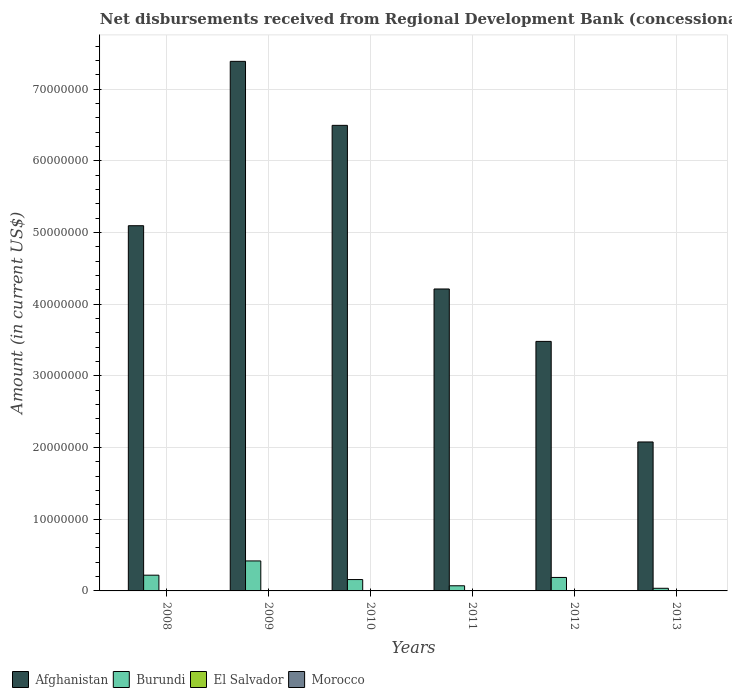How many different coloured bars are there?
Your response must be concise. 2. How many groups of bars are there?
Your response must be concise. 6. Are the number of bars per tick equal to the number of legend labels?
Make the answer very short. No. Are the number of bars on each tick of the X-axis equal?
Provide a short and direct response. Yes. How many bars are there on the 1st tick from the left?
Offer a very short reply. 2. What is the label of the 6th group of bars from the left?
Provide a succinct answer. 2013. What is the amount of disbursements received from Regional Development Bank in Afghanistan in 2008?
Ensure brevity in your answer.  5.09e+07. Across all years, what is the maximum amount of disbursements received from Regional Development Bank in Afghanistan?
Your answer should be very brief. 7.39e+07. In which year was the amount of disbursements received from Regional Development Bank in Burundi maximum?
Keep it short and to the point. 2009. What is the total amount of disbursements received from Regional Development Bank in Afghanistan in the graph?
Your response must be concise. 2.87e+08. What is the difference between the amount of disbursements received from Regional Development Bank in Burundi in 2008 and that in 2010?
Make the answer very short. 6.10e+05. What is the difference between the amount of disbursements received from Regional Development Bank in El Salvador in 2010 and the amount of disbursements received from Regional Development Bank in Burundi in 2013?
Offer a very short reply. -3.68e+05. What is the average amount of disbursements received from Regional Development Bank in Burundi per year?
Give a very brief answer. 1.82e+06. In the year 2013, what is the difference between the amount of disbursements received from Regional Development Bank in Afghanistan and amount of disbursements received from Regional Development Bank in Burundi?
Make the answer very short. 2.04e+07. In how many years, is the amount of disbursements received from Regional Development Bank in Afghanistan greater than 28000000 US$?
Ensure brevity in your answer.  5. What is the ratio of the amount of disbursements received from Regional Development Bank in Burundi in 2011 to that in 2012?
Make the answer very short. 0.38. Is the amount of disbursements received from Regional Development Bank in Afghanistan in 2009 less than that in 2010?
Your answer should be compact. No. What is the difference between the highest and the second highest amount of disbursements received from Regional Development Bank in Burundi?
Your answer should be compact. 1.99e+06. What is the difference between the highest and the lowest amount of disbursements received from Regional Development Bank in Burundi?
Your response must be concise. 3.82e+06. In how many years, is the amount of disbursements received from Regional Development Bank in Morocco greater than the average amount of disbursements received from Regional Development Bank in Morocco taken over all years?
Provide a short and direct response. 0. Is the sum of the amount of disbursements received from Regional Development Bank in Burundi in 2012 and 2013 greater than the maximum amount of disbursements received from Regional Development Bank in Afghanistan across all years?
Give a very brief answer. No. Is it the case that in every year, the sum of the amount of disbursements received from Regional Development Bank in Burundi and amount of disbursements received from Regional Development Bank in El Salvador is greater than the amount of disbursements received from Regional Development Bank in Morocco?
Make the answer very short. Yes. What is the difference between two consecutive major ticks on the Y-axis?
Make the answer very short. 1.00e+07. Are the values on the major ticks of Y-axis written in scientific E-notation?
Give a very brief answer. No. Does the graph contain grids?
Keep it short and to the point. Yes. How many legend labels are there?
Provide a succinct answer. 4. How are the legend labels stacked?
Keep it short and to the point. Horizontal. What is the title of the graph?
Provide a succinct answer. Net disbursements received from Regional Development Bank (concessional). Does "Georgia" appear as one of the legend labels in the graph?
Your answer should be very brief. No. What is the label or title of the X-axis?
Your answer should be very brief. Years. What is the label or title of the Y-axis?
Your answer should be very brief. Amount (in current US$). What is the Amount (in current US$) of Afghanistan in 2008?
Keep it short and to the point. 5.09e+07. What is the Amount (in current US$) of Burundi in 2008?
Offer a terse response. 2.20e+06. What is the Amount (in current US$) in El Salvador in 2008?
Keep it short and to the point. 0. What is the Amount (in current US$) in Afghanistan in 2009?
Give a very brief answer. 7.39e+07. What is the Amount (in current US$) of Burundi in 2009?
Your response must be concise. 4.18e+06. What is the Amount (in current US$) of Morocco in 2009?
Your answer should be compact. 0. What is the Amount (in current US$) in Afghanistan in 2010?
Offer a very short reply. 6.49e+07. What is the Amount (in current US$) in Burundi in 2010?
Provide a short and direct response. 1.59e+06. What is the Amount (in current US$) in Afghanistan in 2011?
Ensure brevity in your answer.  4.21e+07. What is the Amount (in current US$) of Burundi in 2011?
Your answer should be compact. 7.18e+05. What is the Amount (in current US$) of Morocco in 2011?
Provide a succinct answer. 0. What is the Amount (in current US$) of Afghanistan in 2012?
Make the answer very short. 3.48e+07. What is the Amount (in current US$) in Burundi in 2012?
Keep it short and to the point. 1.88e+06. What is the Amount (in current US$) of El Salvador in 2012?
Give a very brief answer. 0. What is the Amount (in current US$) in Morocco in 2012?
Your answer should be compact. 0. What is the Amount (in current US$) of Afghanistan in 2013?
Your answer should be very brief. 2.08e+07. What is the Amount (in current US$) in Burundi in 2013?
Your answer should be very brief. 3.68e+05. What is the Amount (in current US$) of El Salvador in 2013?
Give a very brief answer. 0. What is the Amount (in current US$) of Morocco in 2013?
Provide a short and direct response. 0. Across all years, what is the maximum Amount (in current US$) of Afghanistan?
Your response must be concise. 7.39e+07. Across all years, what is the maximum Amount (in current US$) of Burundi?
Give a very brief answer. 4.18e+06. Across all years, what is the minimum Amount (in current US$) in Afghanistan?
Keep it short and to the point. 2.08e+07. Across all years, what is the minimum Amount (in current US$) in Burundi?
Offer a very short reply. 3.68e+05. What is the total Amount (in current US$) in Afghanistan in the graph?
Provide a short and direct response. 2.87e+08. What is the total Amount (in current US$) of Burundi in the graph?
Provide a succinct answer. 1.09e+07. What is the total Amount (in current US$) in El Salvador in the graph?
Offer a terse response. 0. What is the difference between the Amount (in current US$) in Afghanistan in 2008 and that in 2009?
Ensure brevity in your answer.  -2.29e+07. What is the difference between the Amount (in current US$) of Burundi in 2008 and that in 2009?
Ensure brevity in your answer.  -1.99e+06. What is the difference between the Amount (in current US$) in Afghanistan in 2008 and that in 2010?
Provide a short and direct response. -1.40e+07. What is the difference between the Amount (in current US$) of Burundi in 2008 and that in 2010?
Provide a succinct answer. 6.10e+05. What is the difference between the Amount (in current US$) in Afghanistan in 2008 and that in 2011?
Offer a terse response. 8.82e+06. What is the difference between the Amount (in current US$) of Burundi in 2008 and that in 2011?
Provide a short and direct response. 1.48e+06. What is the difference between the Amount (in current US$) in Afghanistan in 2008 and that in 2012?
Your response must be concise. 1.61e+07. What is the difference between the Amount (in current US$) of Burundi in 2008 and that in 2012?
Offer a very short reply. 3.17e+05. What is the difference between the Amount (in current US$) in Afghanistan in 2008 and that in 2013?
Your answer should be very brief. 3.02e+07. What is the difference between the Amount (in current US$) of Burundi in 2008 and that in 2013?
Give a very brief answer. 1.83e+06. What is the difference between the Amount (in current US$) of Afghanistan in 2009 and that in 2010?
Offer a terse response. 8.93e+06. What is the difference between the Amount (in current US$) of Burundi in 2009 and that in 2010?
Make the answer very short. 2.60e+06. What is the difference between the Amount (in current US$) in Afghanistan in 2009 and that in 2011?
Your response must be concise. 3.17e+07. What is the difference between the Amount (in current US$) in Burundi in 2009 and that in 2011?
Offer a very short reply. 3.46e+06. What is the difference between the Amount (in current US$) of Afghanistan in 2009 and that in 2012?
Your answer should be very brief. 3.91e+07. What is the difference between the Amount (in current US$) in Burundi in 2009 and that in 2012?
Give a very brief answer. 2.30e+06. What is the difference between the Amount (in current US$) in Afghanistan in 2009 and that in 2013?
Make the answer very short. 5.31e+07. What is the difference between the Amount (in current US$) in Burundi in 2009 and that in 2013?
Your answer should be very brief. 3.82e+06. What is the difference between the Amount (in current US$) of Afghanistan in 2010 and that in 2011?
Your response must be concise. 2.28e+07. What is the difference between the Amount (in current US$) of Burundi in 2010 and that in 2011?
Your answer should be very brief. 8.68e+05. What is the difference between the Amount (in current US$) of Afghanistan in 2010 and that in 2012?
Keep it short and to the point. 3.01e+07. What is the difference between the Amount (in current US$) of Burundi in 2010 and that in 2012?
Your answer should be very brief. -2.93e+05. What is the difference between the Amount (in current US$) in Afghanistan in 2010 and that in 2013?
Your response must be concise. 4.42e+07. What is the difference between the Amount (in current US$) of Burundi in 2010 and that in 2013?
Provide a short and direct response. 1.22e+06. What is the difference between the Amount (in current US$) of Afghanistan in 2011 and that in 2012?
Your response must be concise. 7.31e+06. What is the difference between the Amount (in current US$) in Burundi in 2011 and that in 2012?
Your answer should be very brief. -1.16e+06. What is the difference between the Amount (in current US$) of Afghanistan in 2011 and that in 2013?
Offer a terse response. 2.13e+07. What is the difference between the Amount (in current US$) of Afghanistan in 2012 and that in 2013?
Your answer should be very brief. 1.40e+07. What is the difference between the Amount (in current US$) in Burundi in 2012 and that in 2013?
Provide a succinct answer. 1.51e+06. What is the difference between the Amount (in current US$) of Afghanistan in 2008 and the Amount (in current US$) of Burundi in 2009?
Offer a terse response. 4.68e+07. What is the difference between the Amount (in current US$) in Afghanistan in 2008 and the Amount (in current US$) in Burundi in 2010?
Give a very brief answer. 4.94e+07. What is the difference between the Amount (in current US$) of Afghanistan in 2008 and the Amount (in current US$) of Burundi in 2011?
Provide a short and direct response. 5.02e+07. What is the difference between the Amount (in current US$) in Afghanistan in 2008 and the Amount (in current US$) in Burundi in 2012?
Give a very brief answer. 4.91e+07. What is the difference between the Amount (in current US$) of Afghanistan in 2008 and the Amount (in current US$) of Burundi in 2013?
Your answer should be very brief. 5.06e+07. What is the difference between the Amount (in current US$) in Afghanistan in 2009 and the Amount (in current US$) in Burundi in 2010?
Offer a terse response. 7.23e+07. What is the difference between the Amount (in current US$) of Afghanistan in 2009 and the Amount (in current US$) of Burundi in 2011?
Offer a very short reply. 7.31e+07. What is the difference between the Amount (in current US$) in Afghanistan in 2009 and the Amount (in current US$) in Burundi in 2012?
Your answer should be compact. 7.20e+07. What is the difference between the Amount (in current US$) in Afghanistan in 2009 and the Amount (in current US$) in Burundi in 2013?
Provide a succinct answer. 7.35e+07. What is the difference between the Amount (in current US$) of Afghanistan in 2010 and the Amount (in current US$) of Burundi in 2011?
Provide a short and direct response. 6.42e+07. What is the difference between the Amount (in current US$) of Afghanistan in 2010 and the Amount (in current US$) of Burundi in 2012?
Your response must be concise. 6.31e+07. What is the difference between the Amount (in current US$) in Afghanistan in 2010 and the Amount (in current US$) in Burundi in 2013?
Offer a very short reply. 6.46e+07. What is the difference between the Amount (in current US$) in Afghanistan in 2011 and the Amount (in current US$) in Burundi in 2012?
Your answer should be compact. 4.02e+07. What is the difference between the Amount (in current US$) in Afghanistan in 2011 and the Amount (in current US$) in Burundi in 2013?
Ensure brevity in your answer.  4.17e+07. What is the difference between the Amount (in current US$) in Afghanistan in 2012 and the Amount (in current US$) in Burundi in 2013?
Keep it short and to the point. 3.44e+07. What is the average Amount (in current US$) of Afghanistan per year?
Offer a terse response. 4.79e+07. What is the average Amount (in current US$) in Burundi per year?
Ensure brevity in your answer.  1.82e+06. In the year 2008, what is the difference between the Amount (in current US$) in Afghanistan and Amount (in current US$) in Burundi?
Give a very brief answer. 4.87e+07. In the year 2009, what is the difference between the Amount (in current US$) in Afghanistan and Amount (in current US$) in Burundi?
Provide a short and direct response. 6.97e+07. In the year 2010, what is the difference between the Amount (in current US$) in Afghanistan and Amount (in current US$) in Burundi?
Provide a short and direct response. 6.33e+07. In the year 2011, what is the difference between the Amount (in current US$) in Afghanistan and Amount (in current US$) in Burundi?
Provide a short and direct response. 4.14e+07. In the year 2012, what is the difference between the Amount (in current US$) of Afghanistan and Amount (in current US$) of Burundi?
Make the answer very short. 3.29e+07. In the year 2013, what is the difference between the Amount (in current US$) of Afghanistan and Amount (in current US$) of Burundi?
Your answer should be very brief. 2.04e+07. What is the ratio of the Amount (in current US$) in Afghanistan in 2008 to that in 2009?
Make the answer very short. 0.69. What is the ratio of the Amount (in current US$) of Burundi in 2008 to that in 2009?
Offer a very short reply. 0.53. What is the ratio of the Amount (in current US$) of Afghanistan in 2008 to that in 2010?
Keep it short and to the point. 0.78. What is the ratio of the Amount (in current US$) of Burundi in 2008 to that in 2010?
Make the answer very short. 1.38. What is the ratio of the Amount (in current US$) in Afghanistan in 2008 to that in 2011?
Provide a short and direct response. 1.21. What is the ratio of the Amount (in current US$) in Burundi in 2008 to that in 2011?
Keep it short and to the point. 3.06. What is the ratio of the Amount (in current US$) of Afghanistan in 2008 to that in 2012?
Keep it short and to the point. 1.46. What is the ratio of the Amount (in current US$) in Burundi in 2008 to that in 2012?
Your answer should be very brief. 1.17. What is the ratio of the Amount (in current US$) in Afghanistan in 2008 to that in 2013?
Offer a terse response. 2.45. What is the ratio of the Amount (in current US$) in Burundi in 2008 to that in 2013?
Keep it short and to the point. 5.97. What is the ratio of the Amount (in current US$) in Afghanistan in 2009 to that in 2010?
Your answer should be very brief. 1.14. What is the ratio of the Amount (in current US$) in Burundi in 2009 to that in 2010?
Give a very brief answer. 2.64. What is the ratio of the Amount (in current US$) of Afghanistan in 2009 to that in 2011?
Ensure brevity in your answer.  1.75. What is the ratio of the Amount (in current US$) in Burundi in 2009 to that in 2011?
Your answer should be very brief. 5.83. What is the ratio of the Amount (in current US$) of Afghanistan in 2009 to that in 2012?
Make the answer very short. 2.12. What is the ratio of the Amount (in current US$) of Burundi in 2009 to that in 2012?
Give a very brief answer. 2.23. What is the ratio of the Amount (in current US$) of Afghanistan in 2009 to that in 2013?
Give a very brief answer. 3.56. What is the ratio of the Amount (in current US$) in Burundi in 2009 to that in 2013?
Give a very brief answer. 11.37. What is the ratio of the Amount (in current US$) of Afghanistan in 2010 to that in 2011?
Your answer should be very brief. 1.54. What is the ratio of the Amount (in current US$) of Burundi in 2010 to that in 2011?
Give a very brief answer. 2.21. What is the ratio of the Amount (in current US$) in Afghanistan in 2010 to that in 2012?
Your answer should be very brief. 1.87. What is the ratio of the Amount (in current US$) in Burundi in 2010 to that in 2012?
Provide a succinct answer. 0.84. What is the ratio of the Amount (in current US$) in Afghanistan in 2010 to that in 2013?
Your answer should be compact. 3.13. What is the ratio of the Amount (in current US$) of Burundi in 2010 to that in 2013?
Your answer should be very brief. 4.31. What is the ratio of the Amount (in current US$) in Afghanistan in 2011 to that in 2012?
Your answer should be very brief. 1.21. What is the ratio of the Amount (in current US$) in Burundi in 2011 to that in 2012?
Your response must be concise. 0.38. What is the ratio of the Amount (in current US$) of Afghanistan in 2011 to that in 2013?
Provide a short and direct response. 2.03. What is the ratio of the Amount (in current US$) of Burundi in 2011 to that in 2013?
Offer a terse response. 1.95. What is the ratio of the Amount (in current US$) of Afghanistan in 2012 to that in 2013?
Make the answer very short. 1.68. What is the ratio of the Amount (in current US$) in Burundi in 2012 to that in 2013?
Provide a succinct answer. 5.11. What is the difference between the highest and the second highest Amount (in current US$) in Afghanistan?
Provide a succinct answer. 8.93e+06. What is the difference between the highest and the second highest Amount (in current US$) in Burundi?
Ensure brevity in your answer.  1.99e+06. What is the difference between the highest and the lowest Amount (in current US$) in Afghanistan?
Give a very brief answer. 5.31e+07. What is the difference between the highest and the lowest Amount (in current US$) in Burundi?
Offer a very short reply. 3.82e+06. 